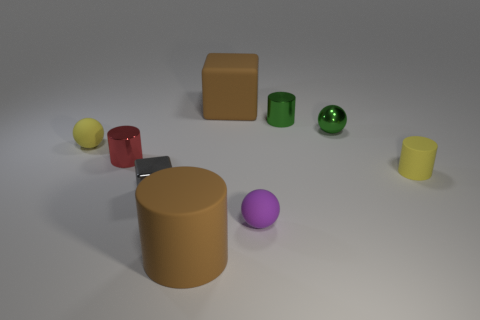Is the number of blocks that are on the left side of the big cube the same as the number of objects?
Keep it short and to the point. No. How many big things are either brown rubber cubes or purple rubber cylinders?
Keep it short and to the point. 1. The thing that is the same color as the big rubber cylinder is what shape?
Give a very brief answer. Cube. Is the material of the ball on the left side of the tiny metallic cube the same as the tiny gray thing?
Ensure brevity in your answer.  No. What material is the block that is in front of the tiny yellow rubber thing that is on the right side of the large matte cube?
Keep it short and to the point. Metal. What number of small yellow objects are the same shape as the purple matte thing?
Your answer should be compact. 1. How big is the matte cylinder that is behind the big brown rubber object that is in front of the tiny yellow thing to the right of the brown rubber block?
Give a very brief answer. Small. What number of green objects are shiny spheres or big blocks?
Ensure brevity in your answer.  1. Do the rubber object on the right side of the tiny purple rubber ball and the red object have the same shape?
Your answer should be compact. Yes. Are there more small metallic balls that are behind the tiny yellow cylinder than large gray matte spheres?
Offer a terse response. Yes. 